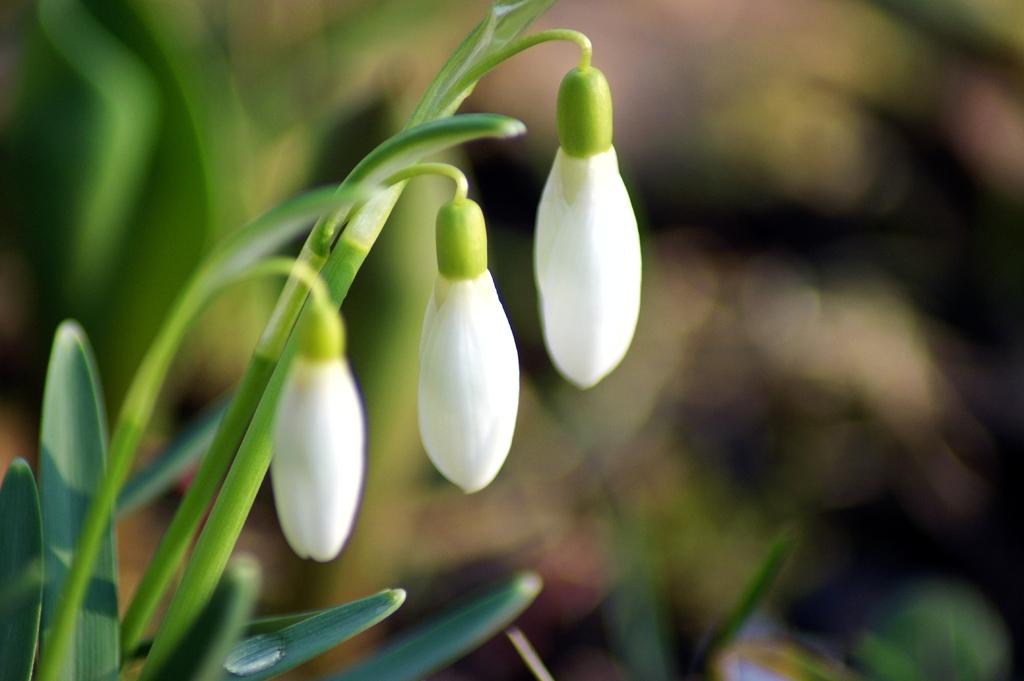What type of plant parts can be seen in the image? There are buds, green leaves, and green stems in the image. What is the color of the leaves and stems in the image? The leaves and stems in the image are green. How would you describe the background of the image? The background of the image is blurry. What else can be seen in the background of the image besides the blur? There are other items visible in the background of the image. What degree does the creator of the image have in botany? There is no information about the creator of the image or their degree in botany, as the focus is on the image itself. 